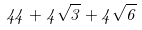Convert formula to latex. <formula><loc_0><loc_0><loc_500><loc_500>4 4 + 4 \sqrt { 3 } + 4 \sqrt { 6 }</formula> 